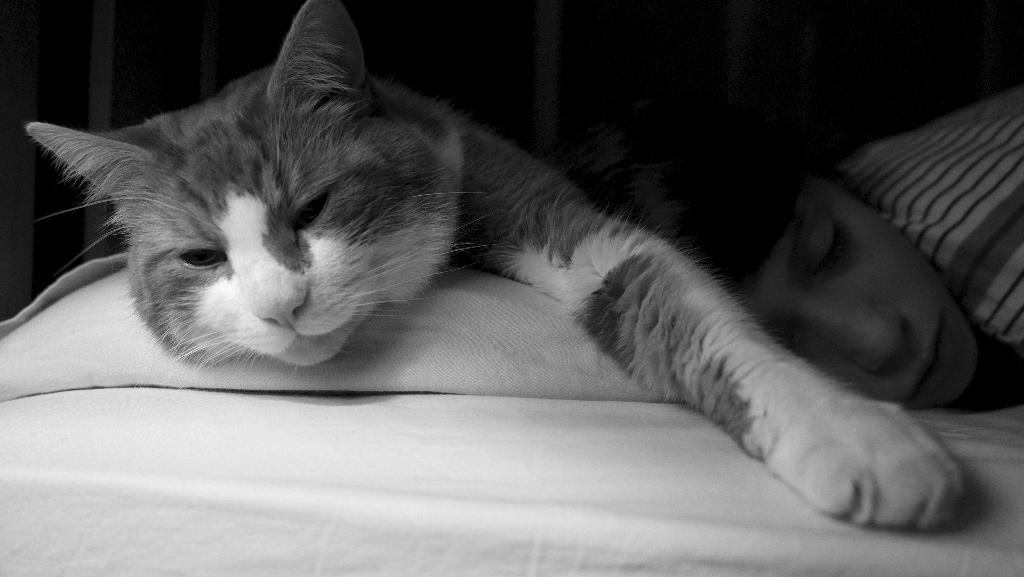What type of animal is present in the image? There is a cat in the image. Where is the cat located? The cat is lying on a bed. Are there any people in the image? Yes, there is a person in the image. What is the color scheme of the image? The image is in black and white color. What is the name of the cat's partner in the image? There is no indication of a partner for the cat in the image. What type of competition is the cat participating in the image? There is no competition present in the image; it is a simple scene of a cat lying on a bed. 